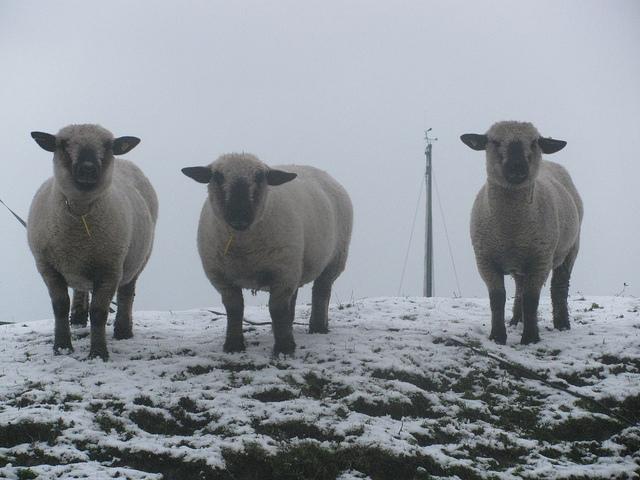Are the animals cold?
Short answer required. Yes. How many sheep are there?
Keep it brief. 3. What textile comes from these animals?
Quick response, please. Wool. 